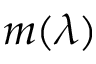Convert formula to latex. <formula><loc_0><loc_0><loc_500><loc_500>m ( \lambda )</formula> 